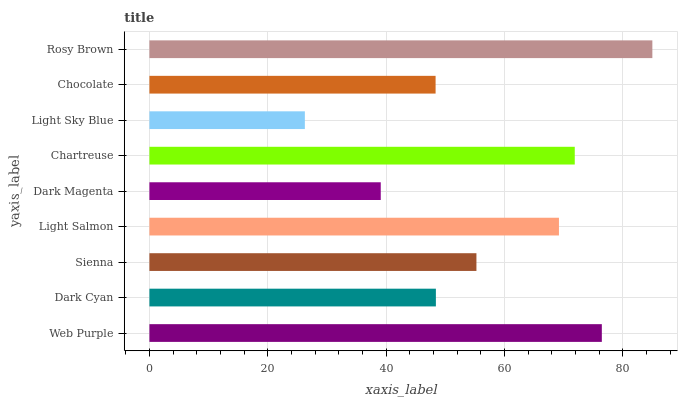Is Light Sky Blue the minimum?
Answer yes or no. Yes. Is Rosy Brown the maximum?
Answer yes or no. Yes. Is Dark Cyan the minimum?
Answer yes or no. No. Is Dark Cyan the maximum?
Answer yes or no. No. Is Web Purple greater than Dark Cyan?
Answer yes or no. Yes. Is Dark Cyan less than Web Purple?
Answer yes or no. Yes. Is Dark Cyan greater than Web Purple?
Answer yes or no. No. Is Web Purple less than Dark Cyan?
Answer yes or no. No. Is Sienna the high median?
Answer yes or no. Yes. Is Sienna the low median?
Answer yes or no. Yes. Is Light Sky Blue the high median?
Answer yes or no. No. Is Light Salmon the low median?
Answer yes or no. No. 